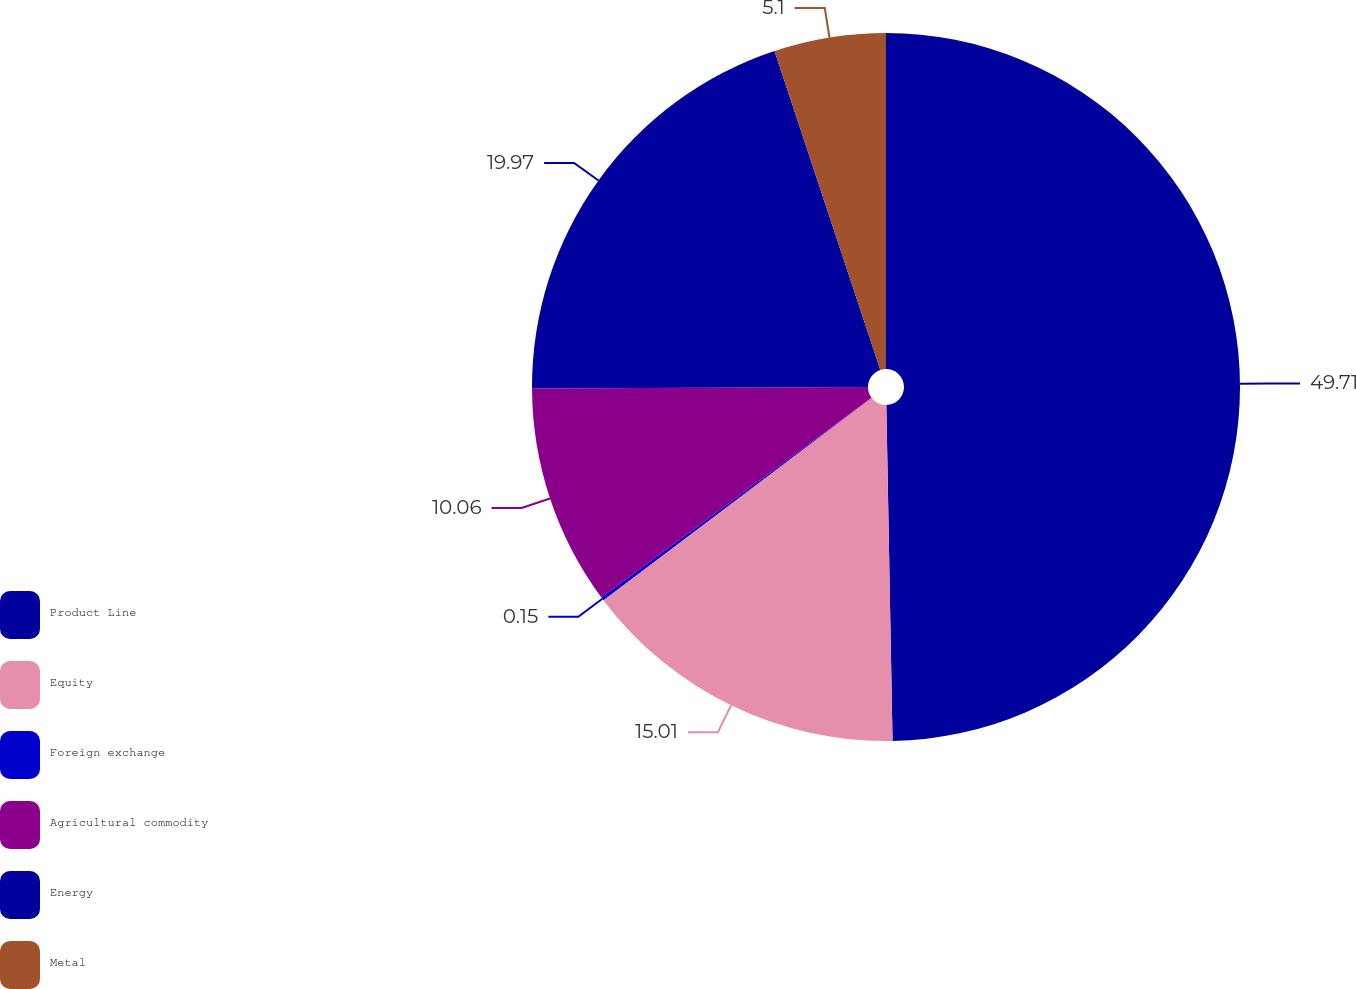<chart> <loc_0><loc_0><loc_500><loc_500><pie_chart><fcel>Product Line<fcel>Equity<fcel>Foreign exchange<fcel>Agricultural commodity<fcel>Energy<fcel>Metal<nl><fcel>49.7%<fcel>15.01%<fcel>0.15%<fcel>10.06%<fcel>19.97%<fcel>5.1%<nl></chart> 